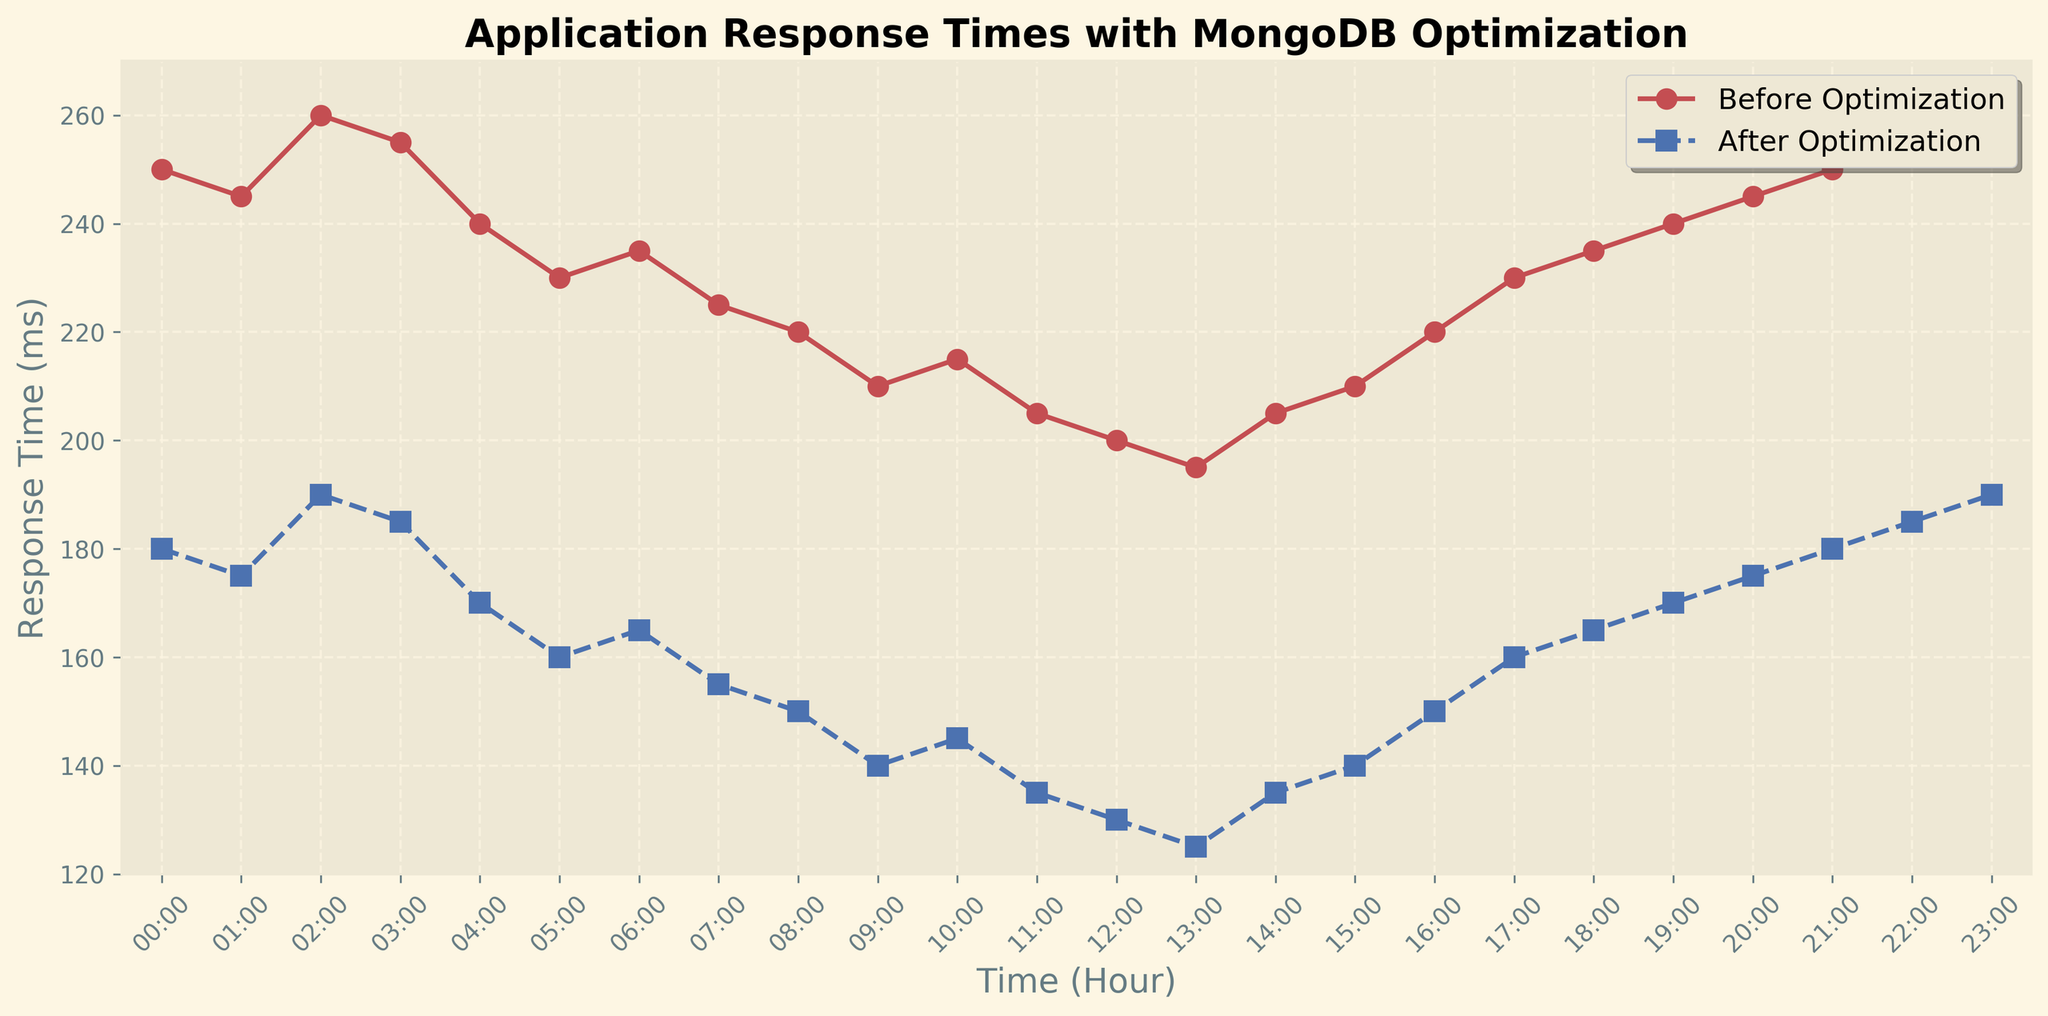What is the maximum response time before optimization? To find the maximum response time before optimization, refer to the 'Before Optimization' line (red color) on the plot and locate the highest point. The highest value on the y-axis where the red line reaches is 260 ms.
Answer: 260 ms How does the average response time before optimization compare to after optimization? First, calculate the average response times for both before and after optimization. For before optimization, sum the values and divide by 24: (250+245+260+255+240+230+235+225+220+210+215+205+200+195+205+210+220+230+235+240+245+250+255+260)/24 = 231.25 ms. For after optimization: (180+175+190+185+170+160+165+155+150+140+145+135+130+125+135+140+150+160+165+170+175+180+185+190)/24 = 162.5 ms. Comparing these, the average response time is lower after optimization.
Answer: The average is 231.25 ms before optimization and 162.5 ms after optimization At what time is the response time the lowest after optimization? To locate the lowest response time after optimization, refer to the 'After Optimization' line (blue color) on the plot and find the lowest point. The lowest value on the y-axis where the blue line reaches is 125 ms, and this occurs at 13:00.
Answer: 13:00 What's the difference in response time before and after optimization at 06:00? Locate the response time values at 06:00 for before and after optimization. Before optimization, the value is 235 ms. After optimization, the value is 165 ms. The difference is 235 - 165 = 70 ms.
Answer: 70 ms Which hour shows the greatest improvement in response time after optimization? Calculate the differences in each hour's response times before and after optimization. The largest difference will indicate the greatest improvement. For each hour:
00:00: 250 - 180 = 70
01:00: 245 - 175 = 70
02:00: 260 - 190 = 70
18:00: 235 - 165 = 70 etc.
The greatest difference is 70 ms, occurring at multiple hours: 00:00, 01:00, 02:00, and 18:00.
Answer: 00:00, 01:00, 02:00, and 18:00 How do the trends of response times before and after optimization differ from 00:00 to 12:00? From 00:00 to 12:00, the 'Before Optimization' line (red color) generally decreases with minor fluctuations, while the 'After Optimization' line (blue color) also decreases but more steeply and consistently. Both lines show an overall downward trend, but the decrease is more pronounced after optimization.
Answer: More steep decrease after optimization What color represents the response times after optimization in the plot? Identify the color used for the 'After Optimization' line in the legend of the plot. The color representing the 'After Optimization' line is blue.
Answer: Blue At what times do both response times, before and after optimization, exceed 250 ms and 180 ms respectively? Check the plot for hours where the 'Before Optimization' line exceeds 250 ms and the 'After Optimization' line exceeds 180 ms. Before optimization, this happens at 00:00, 21:00, and 23:00. After optimization, this does not happen at any hour as 180 ms is the highest value shown after optimization, which is during none of the hours.
Answer: 00:00, 21:00, 23:00 for before; none for after What is the median response time after optimization? List all 24 hours' response times after optimization and find the middle value. If the list has an even number of observations (24 in this case), average the two central numbers. Listing and sorting: 125, 130, 135, 135, 140, 140, 145, 150, 150, 155, 160, 160, 165, 165, 170, 170, 175, 175, 180, 180, 185, 185, 190, 190. The median is the average of 12th and 13th values: (160+165)/2 = 162.5 ms.
Answer: 162.5 ms 